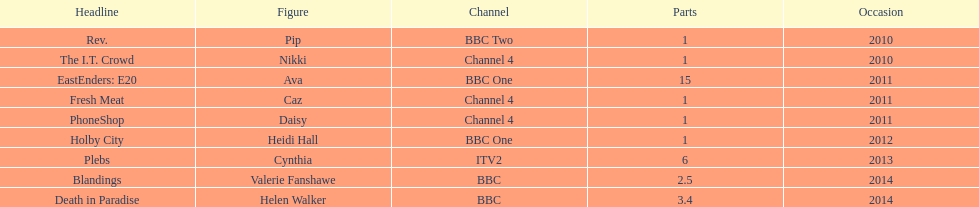What was the previous role this actress played before playing cynthia in plebs? Heidi Hall. 